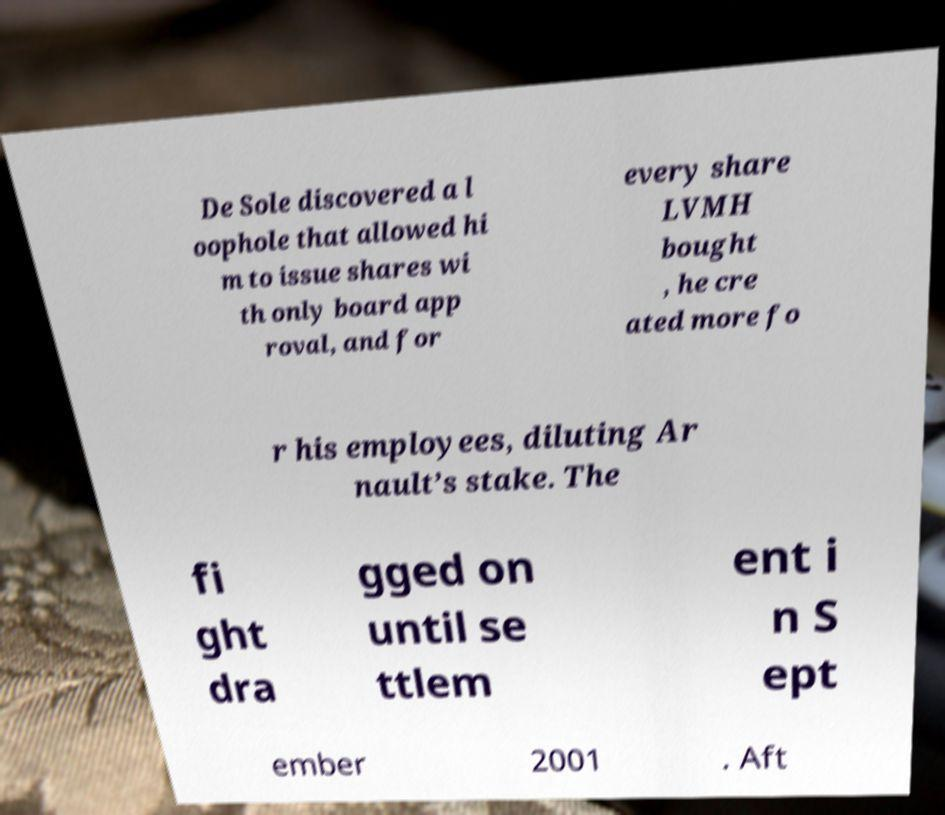Could you extract and type out the text from this image? De Sole discovered a l oophole that allowed hi m to issue shares wi th only board app roval, and for every share LVMH bought , he cre ated more fo r his employees, diluting Ar nault’s stake. The fi ght dra gged on until se ttlem ent i n S ept ember 2001 . Aft 